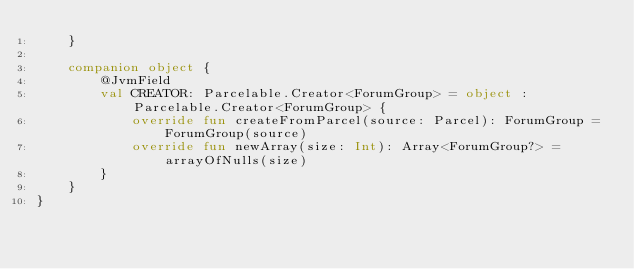Convert code to text. <code><loc_0><loc_0><loc_500><loc_500><_Kotlin_>    }

    companion object {
        @JvmField
        val CREATOR: Parcelable.Creator<ForumGroup> = object : Parcelable.Creator<ForumGroup> {
            override fun createFromParcel(source: Parcel): ForumGroup = ForumGroup(source)
            override fun newArray(size: Int): Array<ForumGroup?> = arrayOfNulls(size)
        }
    }
}</code> 